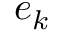<formula> <loc_0><loc_0><loc_500><loc_500>e _ { k }</formula> 